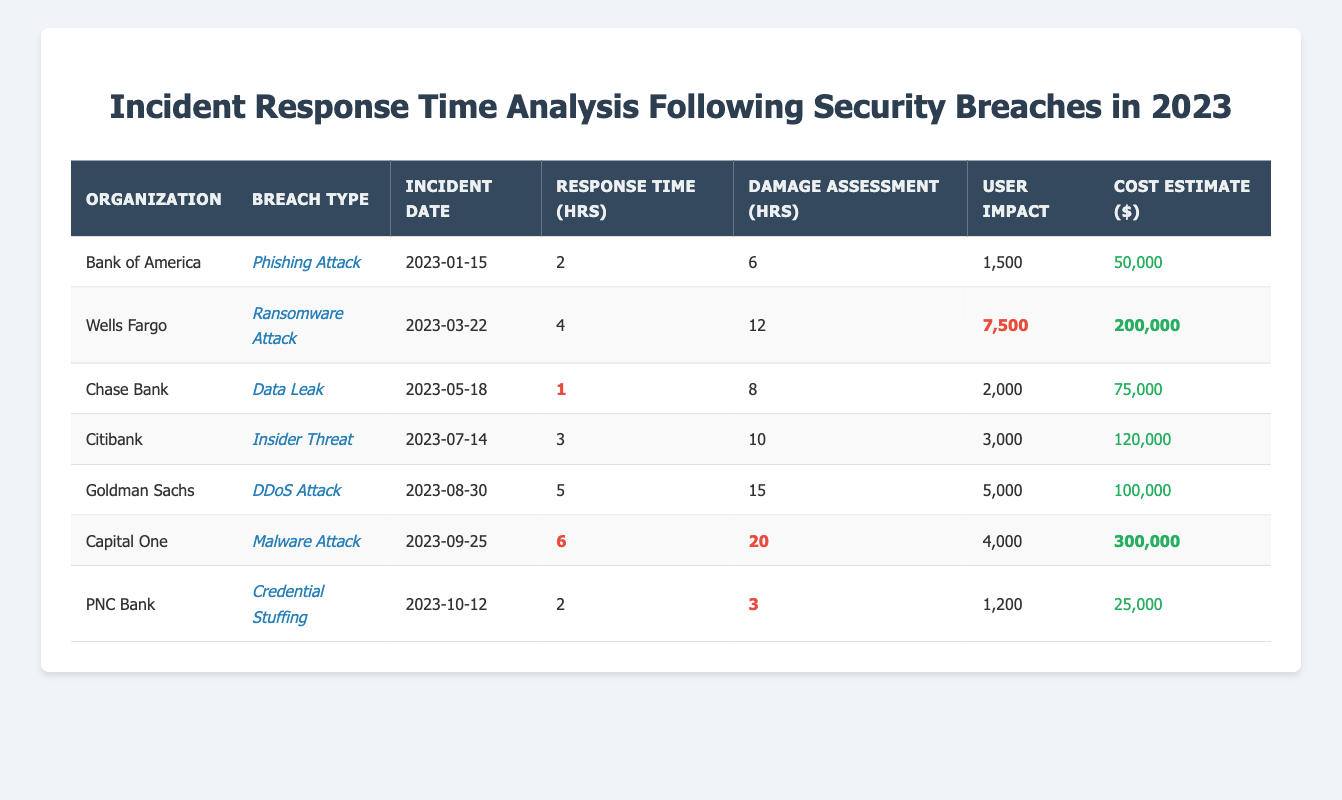What is the response time for the phishing attack at Bank of America? The table shows that the response time for the phishing attack at Bank of America is listed under "Response Time (hrs)" in the corresponding row, which indicates a value of 2 hours.
Answer: 2 hours Which organization experienced the longest damage assessment time, and what was that time? By examining the "Damage Assessment (hrs)" column, I see that Capital One has the highest value of 20 hours listed under its respective row for malware attack.
Answer: Capital One, 20 hours How many users were impacted by the ransomware attack at Wells Fargo? The "User Impact" column for Wells Fargo's row indicates that 7,500 users were affected by the ransomware attack.
Answer: 7,500 users Which breach type had the fastest response time, and what was that time? The table lists the response time for each breach. The fastest is 1 hour for the data leak at Chase Bank, as seen in the "Response Time (hrs)" column.
Answer: Data Leak, 1 hour What is the total estimated cost of the security incidents listed in the table? I add up all the values in the "Cost Estimate ($)" column: 50,000 + 200,000 + 75,000 + 120,000 + 100,000 + 300,000 + 25,000 = 870,000.
Answer: 870,000 dollars Is the user impact higher for the insider threat incident at Citibank compared to the DDoS attack at Goldman Sachs? Comparing the "User Impact" values, Citibank has 3,000 users impacted while Goldman Sachs has 5,000. Therefore, the user impact for the insider threat is lower than for the DDoS attack.
Answer: No What is the average response time across all incidents listed in the table? To find the average response time, I sum the values: 2 + 4 + 1 + 3 + 5 + 6 + 2 = 23. Then I divide by the total number of incidents (7), resulting in an average of 23/7 ≈ 3.29 hours.
Answer: Approximately 3.29 hours Which incident resulted in the highest cost estimate, and what was that cost? Looking at the "Cost Estimate ($)" column, Capital One's malware attack is the highest at 300,000, as indicated in its row.
Answer: Capital One, 300,000 dollars How does the user impact of the phishing attack at Bank of America compare to that of the credential stuffing at PNC Bank? Bank of America shows a user impact of 1,500 while PNC Bank shows an impact of 1,200. Since 1,500 is greater than 1,200, it indicates a higher impact for the phishing attack.
Answer: Higher for Bank of America What is the difference in response time between the ransomware attack at Wells Fargo and the malware attack at Capital One? The response times are 4 hours for Wells Fargo and 6 hours for Capital One. The difference is 6 - 4 = 2 hours.
Answer: 2 hours 